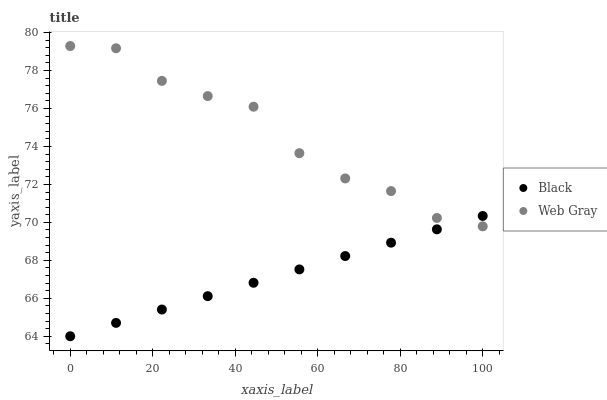Does Black have the minimum area under the curve?
Answer yes or no. Yes. Does Web Gray have the maximum area under the curve?
Answer yes or no. Yes. Does Black have the maximum area under the curve?
Answer yes or no. No. Is Black the smoothest?
Answer yes or no. Yes. Is Web Gray the roughest?
Answer yes or no. Yes. Is Black the roughest?
Answer yes or no. No. Does Black have the lowest value?
Answer yes or no. Yes. Does Web Gray have the highest value?
Answer yes or no. Yes. Does Black have the highest value?
Answer yes or no. No. Does Web Gray intersect Black?
Answer yes or no. Yes. Is Web Gray less than Black?
Answer yes or no. No. Is Web Gray greater than Black?
Answer yes or no. No. 